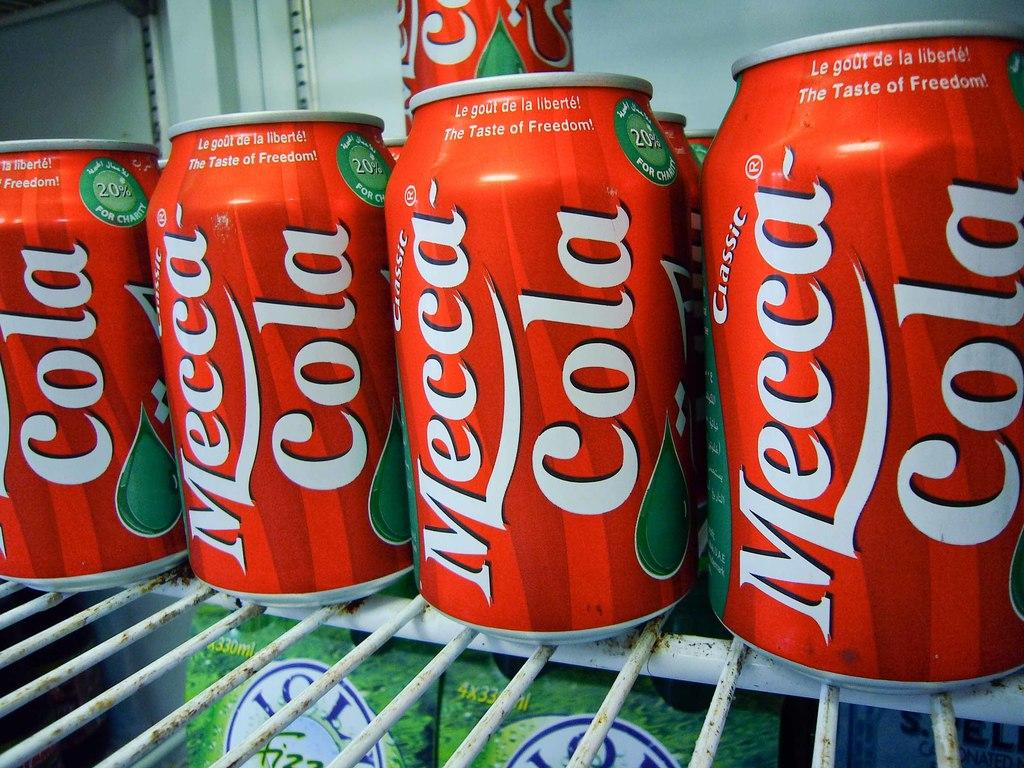<image>
Present a compact description of the photo's key features. Cans of Mecca Cola that are in a refrigerator. lined up together. 